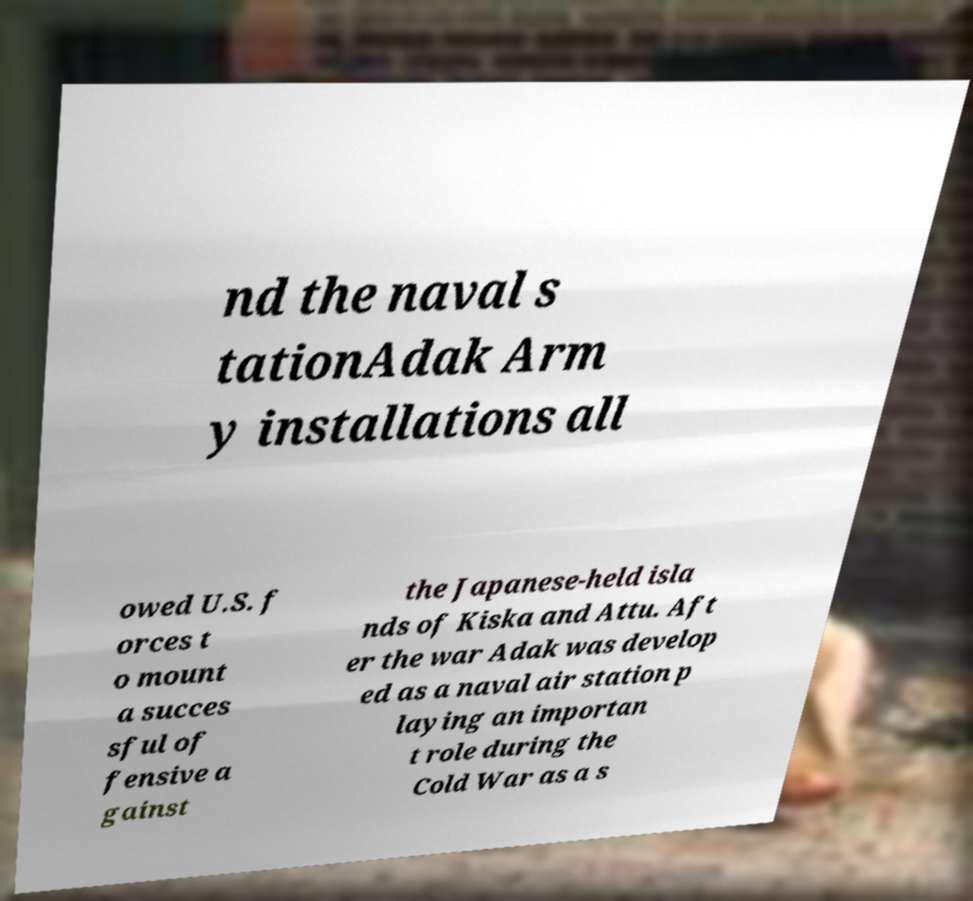Please identify and transcribe the text found in this image. nd the naval s tationAdak Arm y installations all owed U.S. f orces t o mount a succes sful of fensive a gainst the Japanese-held isla nds of Kiska and Attu. Aft er the war Adak was develop ed as a naval air station p laying an importan t role during the Cold War as a s 